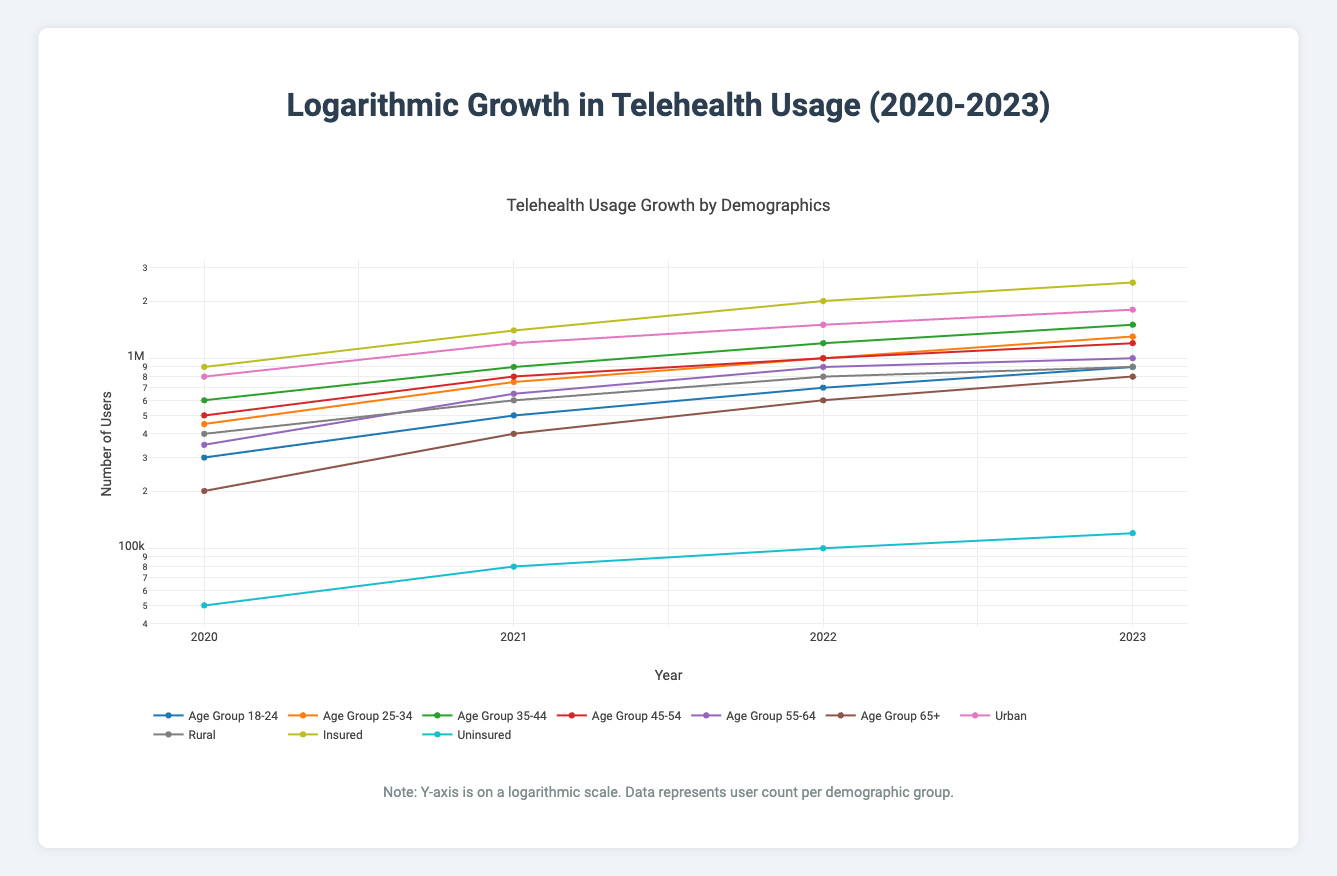What was the telehealth usage for the age group 35-44 in 2021? In 2021, the table indicates that the telehealth usage for the age group 35-44 was 900,000. This value is directly referenced from the 2021 data for the 35-44 age group.
Answer: 900,000 Which age group had the highest telehealth usage in 2023? In 2023, the data shows that the age group 35-44 had the highest telehealth usage with a count of 1,500,000 users. This is the greatest value listed for all age groups under that year.
Answer: 1,500,000 What is the total number of telehealth users reported in urban areas across all years? The urban telehealth users for each year are 800,000 (2020) + 1,200,000 (2021) + 1,500,000 (2022) + 1,800,000 (2023) = 4,300,000. This sum combines the urban usage figures across the four years.
Answer: 4,300,000 Did the number of uninsured telehealth users increase from 2021 to 2023? The table shows that uninsured telehealth users numbered 80,000 in 2021 and increased to 120,000 in 2023. Since 120,000 is greater than 80,000, the statement is true.
Answer: Yes What is the percentage increase in telehealth usage for the 18-24 age group from 2020 to 2023? In 2020, the usage was 300,000 for the age group 18-24, and in 2023, it rose to 900,000. The percentage increase can be calculated as: ((900,000 - 300,000) / 300,000) * 100 = 200%. This indicates a threefold increase over the three years.
Answer: 200% What was the average telehealth usage across the age groups in 2022? The total telehealth users across all age groups in 2022 are 700,000 (18-24) + 1,000,000 (25-34) + 1,200,000 (35-44) + 1,000,000 (45-54) + 900,000 (55-64) + 600,000 (65+) = 4,600,000. There are 6 age groups, so the average is 4,600,000 / 6 = 766,667.
Answer: 766,667 What was the growth trend in telehealth usage from Rural to Urban areas from 2020 to 2023? In 2020, Urban usage was 800,000 and Rural was 400,000. By 2023, Urban had increased to 1,800,000 and Rural to 900,000. The increases indicate a trend towards Urban growth, with Urban growing by 1,000,000 (from 800,000 to 1,800,000) and Rural by 500,000 (from 400,000 to 900,000), showcasing significantly higher growth in Urban areas.
Answer: Urban increased significantly more What was the total telehealth usage in 2021 for both insured and uninsured individuals? In 2021, the table values indicate that there were 1,400,000 insured and 80,000 uninsured users. Summing these yields 1,400,000 + 80,000 = 1,480,000. This total combines both insured and uninsured telehealth users for that year.
Answer: 1,480,000 How did the telehealth usage change for the age group 55-64 from 2020 to 2022? For the age group 55-64, the usage was 350,000 in 2020 and increased to 900,000 in 2022. This is an increase of 900,000 - 350,000 = 550,000, showcasing a significant rise of 157% over those two years.
Answer: Increased by 550,000 